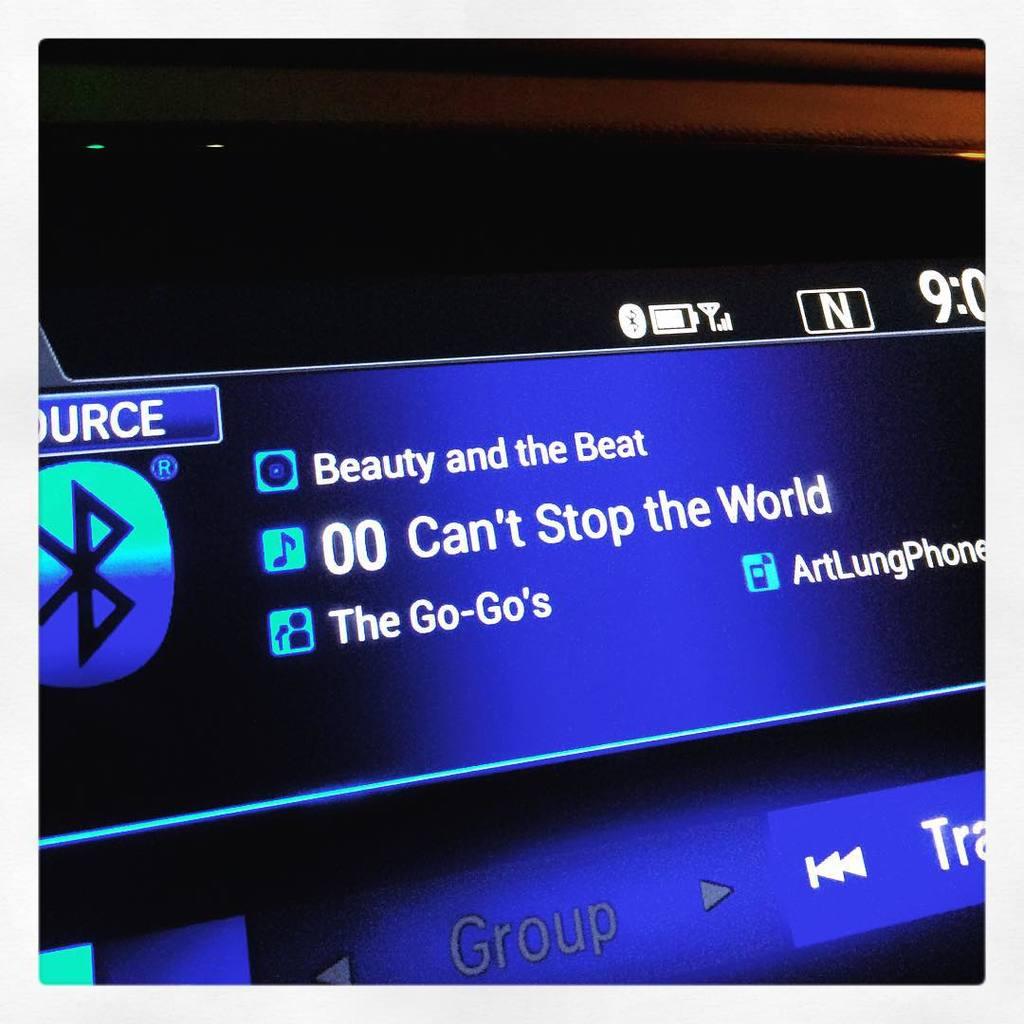What is the song title?
Provide a short and direct response. Can't stop the world. 